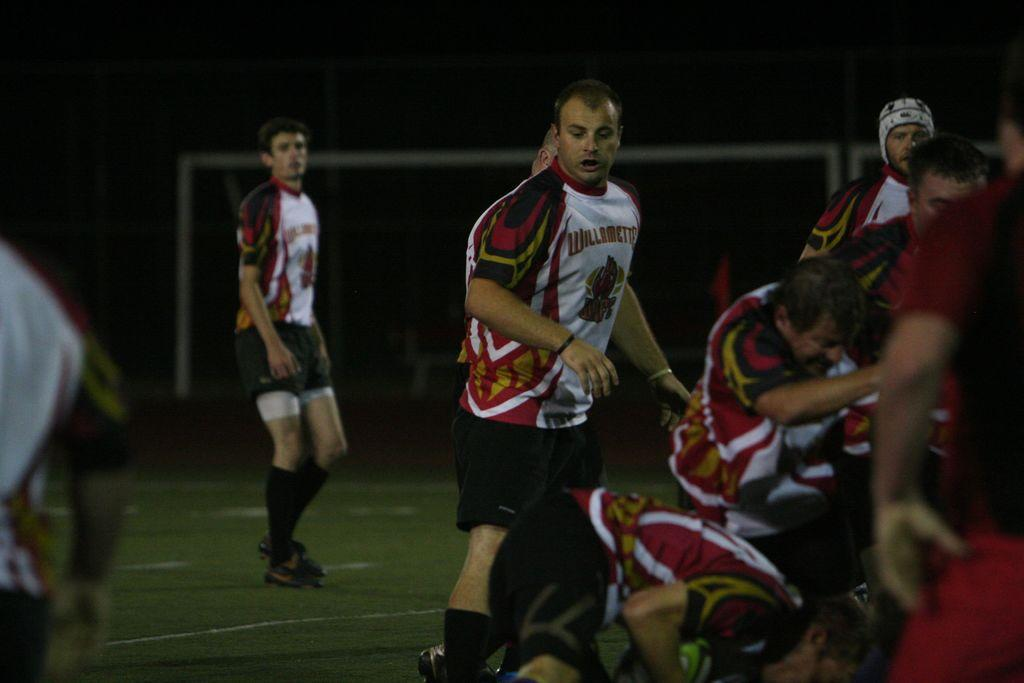<image>
Summarize the visual content of the image. Several gentlemen, wearing red, black and white uniforms, are playing rugby with the team name of Williamette. 